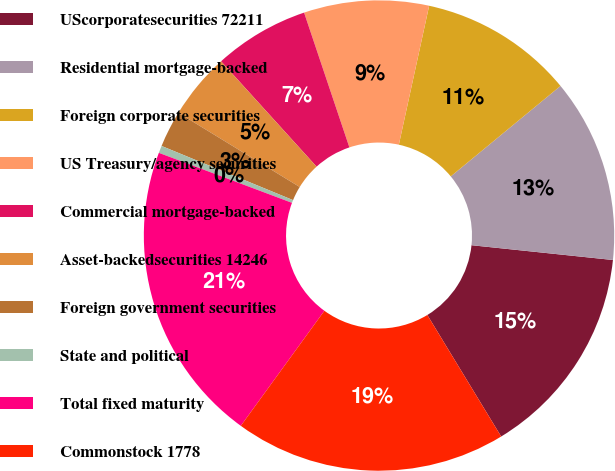Convert chart. <chart><loc_0><loc_0><loc_500><loc_500><pie_chart><fcel>UScorporatesecurities 72211<fcel>Residential mortgage-backed<fcel>Foreign corporate securities<fcel>US Treasury/agency securities<fcel>Commercial mortgage-backed<fcel>Asset-backedsecurities 14246<fcel>Foreign government securities<fcel>State and political<fcel>Total fixed maturity<fcel>Commonstock 1778<nl><fcel>14.65%<fcel>12.63%<fcel>10.61%<fcel>8.58%<fcel>6.56%<fcel>4.54%<fcel>2.52%<fcel>0.5%<fcel>20.72%<fcel>18.69%<nl></chart> 